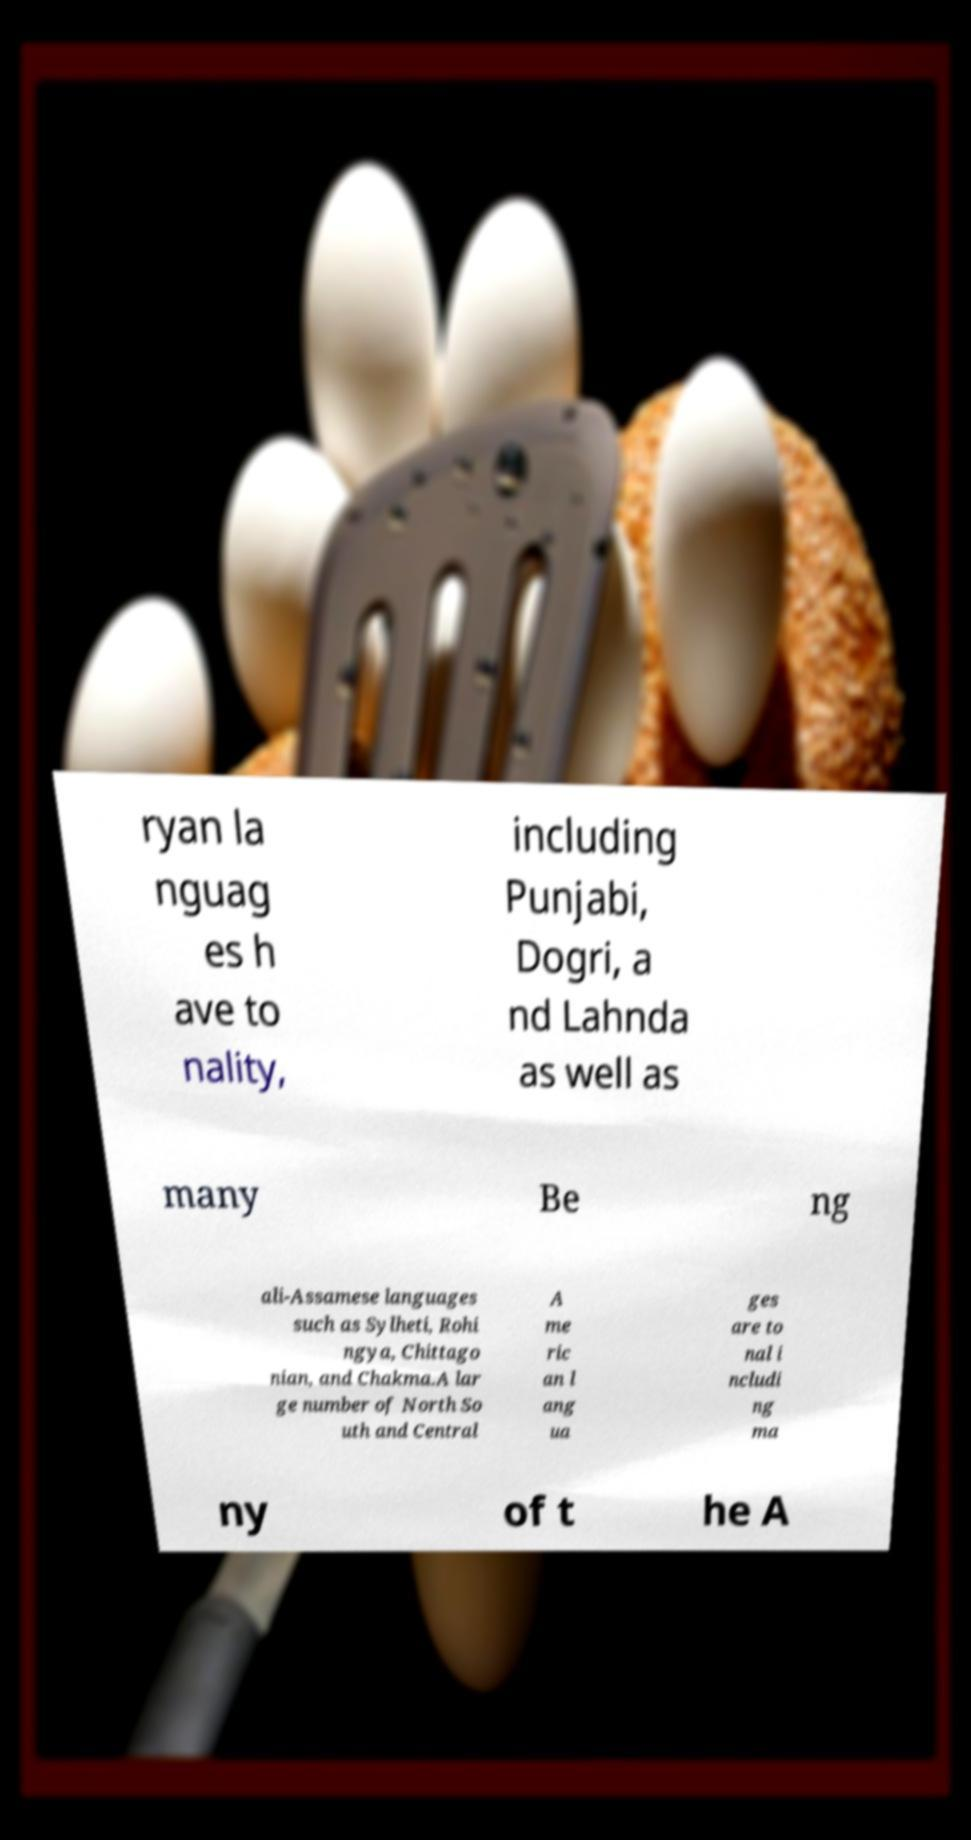Can you read and provide the text displayed in the image?This photo seems to have some interesting text. Can you extract and type it out for me? ryan la nguag es h ave to nality, including Punjabi, Dogri, a nd Lahnda as well as many Be ng ali-Assamese languages such as Sylheti, Rohi ngya, Chittago nian, and Chakma.A lar ge number of North So uth and Central A me ric an l ang ua ges are to nal i ncludi ng ma ny of t he A 